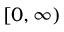<formula> <loc_0><loc_0><loc_500><loc_500>[ 0 , \infty )</formula> 